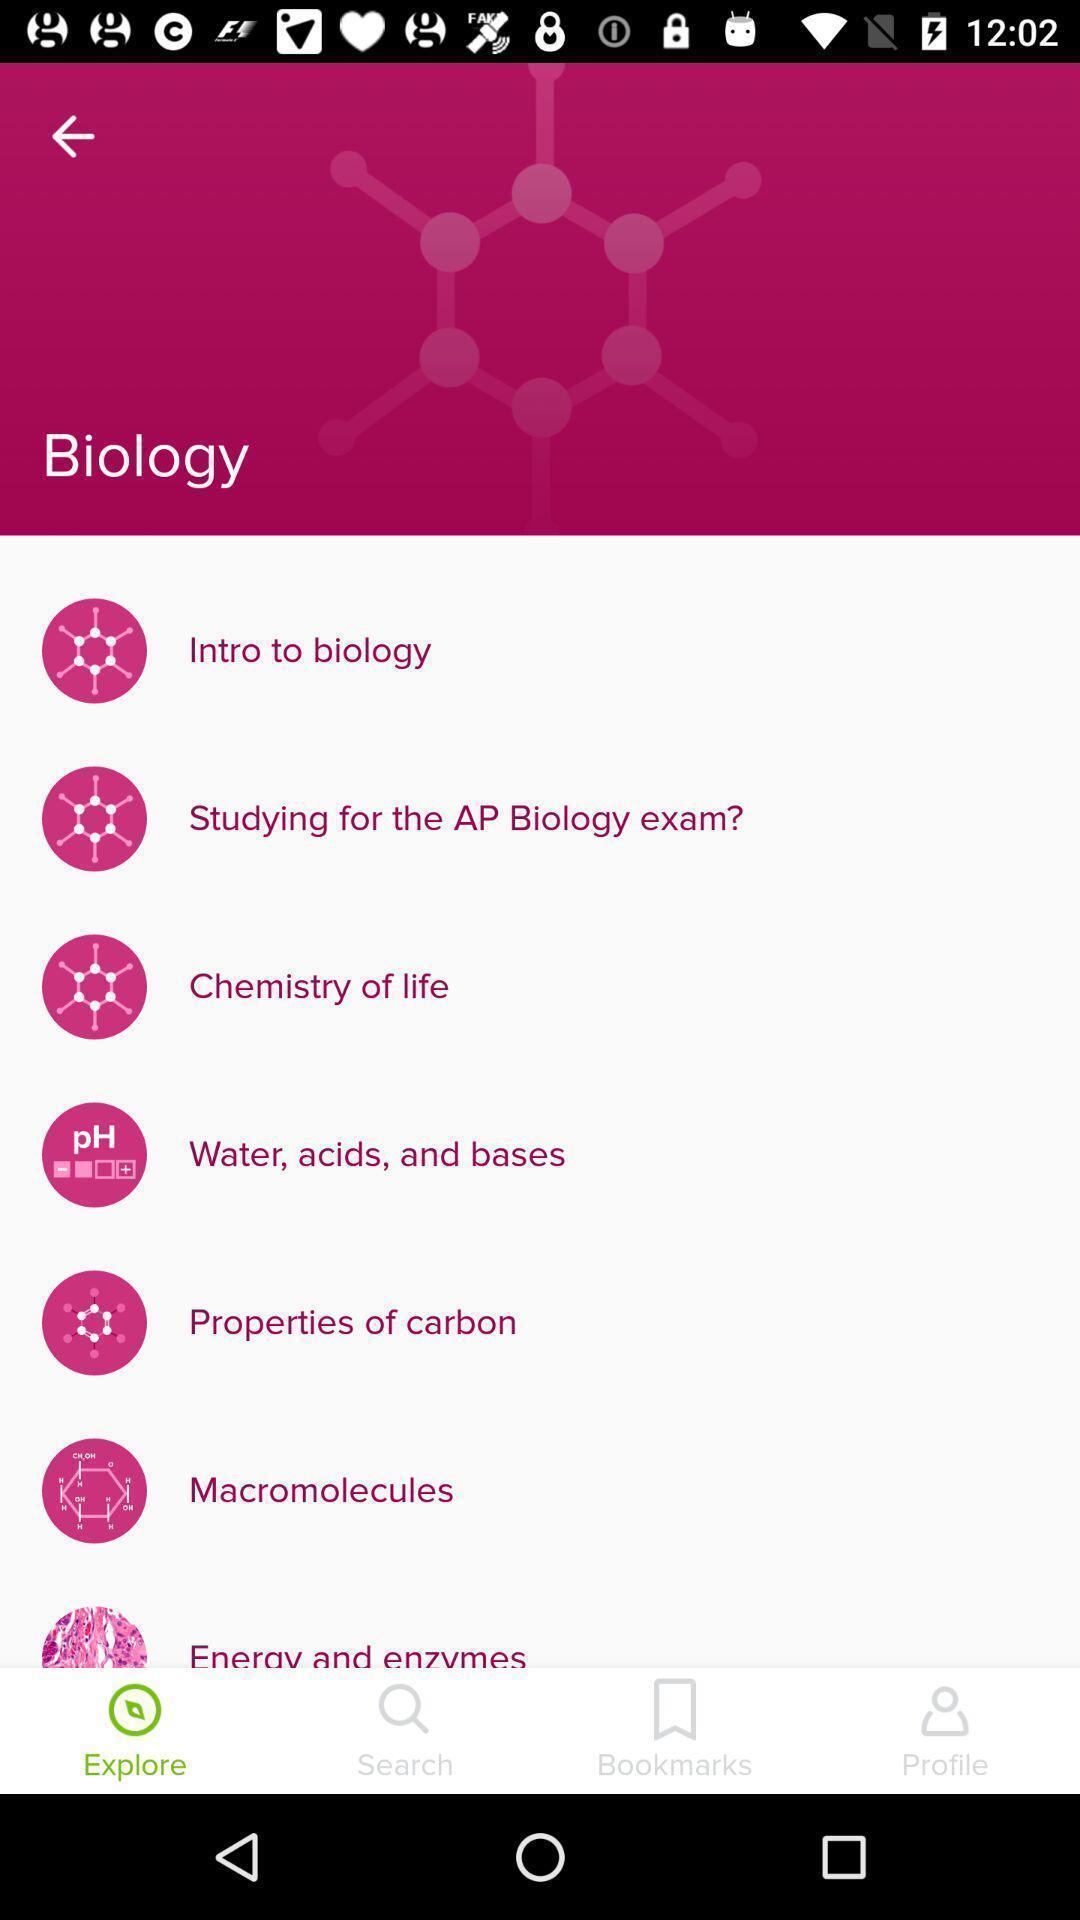What details can you identify in this image? Screen displaying topics under biology. 